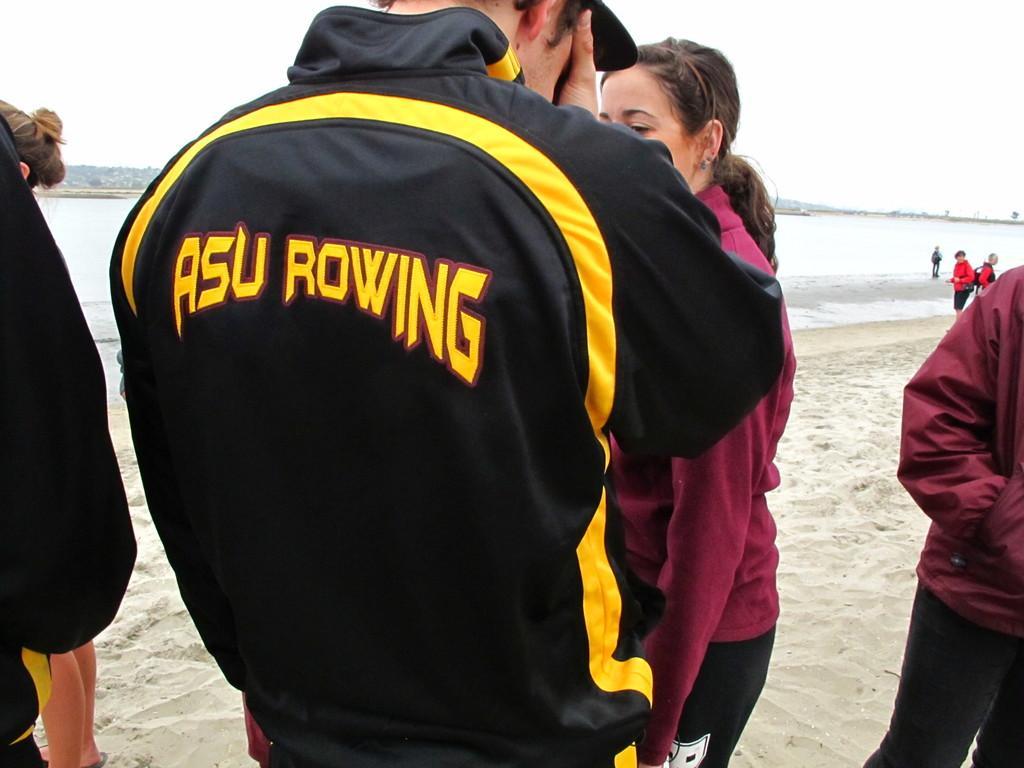Please provide a concise description of this image. In this image I can see there are persons standing on a sand. And there is a water and a mountain. 